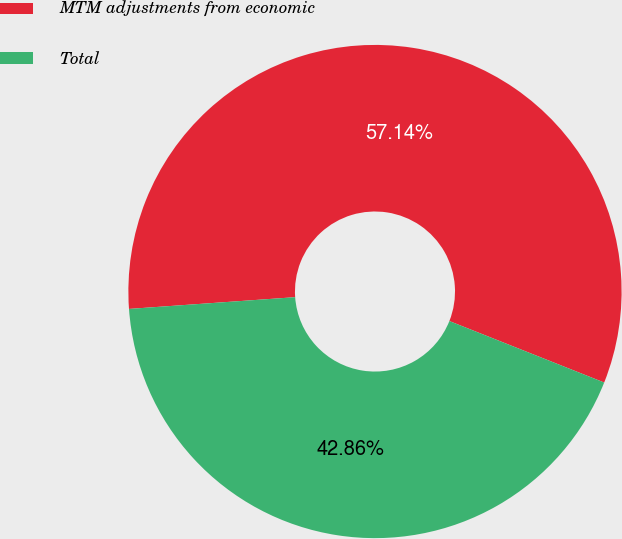<chart> <loc_0><loc_0><loc_500><loc_500><pie_chart><fcel>MTM adjustments from economic<fcel>Total<nl><fcel>57.14%<fcel>42.86%<nl></chart> 